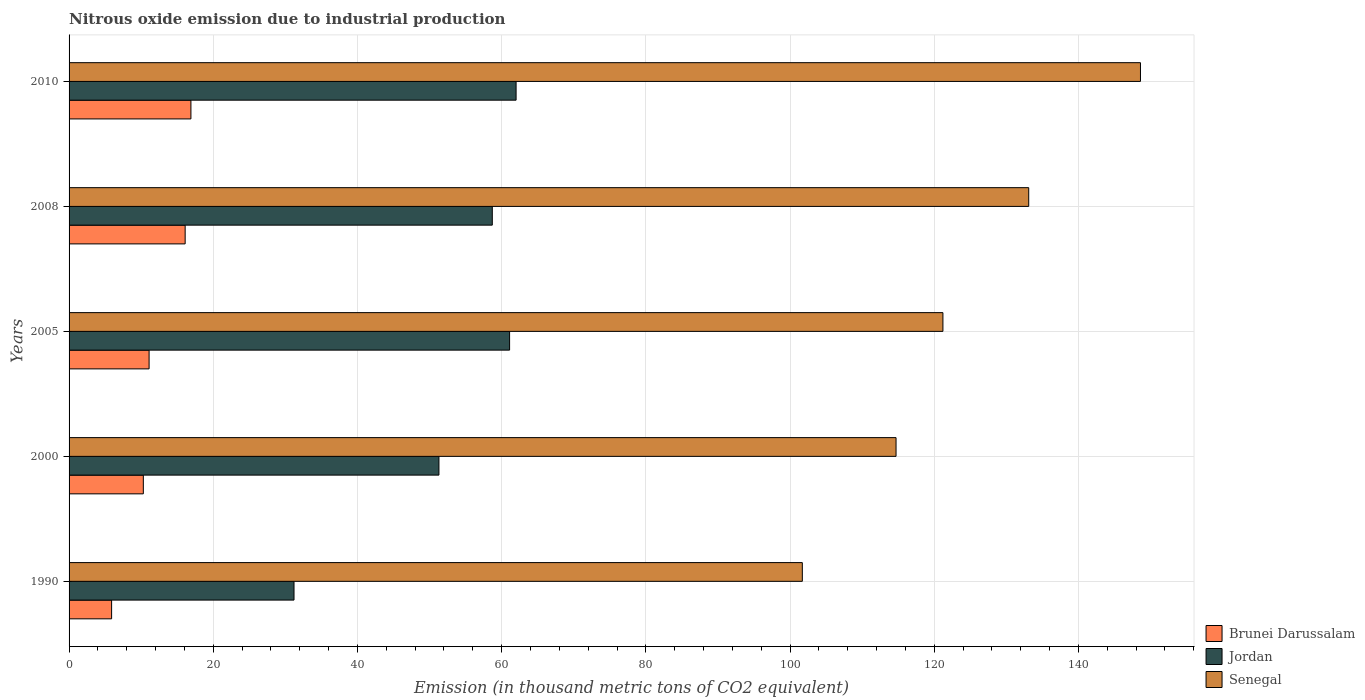How many groups of bars are there?
Offer a very short reply. 5. Are the number of bars per tick equal to the number of legend labels?
Offer a very short reply. Yes. Are the number of bars on each tick of the Y-axis equal?
Ensure brevity in your answer.  Yes. What is the amount of nitrous oxide emitted in Senegal in 2008?
Ensure brevity in your answer.  133.1. Across all years, what is the maximum amount of nitrous oxide emitted in Brunei Darussalam?
Provide a succinct answer. 16.9. In which year was the amount of nitrous oxide emitted in Brunei Darussalam maximum?
Provide a succinct answer. 2010. What is the total amount of nitrous oxide emitted in Senegal in the graph?
Provide a short and direct response. 619.3. What is the difference between the amount of nitrous oxide emitted in Jordan in 1990 and that in 2000?
Offer a very short reply. -20.1. What is the difference between the amount of nitrous oxide emitted in Brunei Darussalam in 2005 and the amount of nitrous oxide emitted in Senegal in 2008?
Keep it short and to the point. -122. What is the average amount of nitrous oxide emitted in Jordan per year?
Give a very brief answer. 52.86. In the year 2008, what is the difference between the amount of nitrous oxide emitted in Brunei Darussalam and amount of nitrous oxide emitted in Senegal?
Provide a succinct answer. -117. What is the ratio of the amount of nitrous oxide emitted in Brunei Darussalam in 2000 to that in 2008?
Your response must be concise. 0.64. What is the difference between the highest and the second highest amount of nitrous oxide emitted in Brunei Darussalam?
Your response must be concise. 0.8. What is the difference between the highest and the lowest amount of nitrous oxide emitted in Senegal?
Keep it short and to the point. 46.9. In how many years, is the amount of nitrous oxide emitted in Jordan greater than the average amount of nitrous oxide emitted in Jordan taken over all years?
Make the answer very short. 3. Is the sum of the amount of nitrous oxide emitted in Brunei Darussalam in 2005 and 2008 greater than the maximum amount of nitrous oxide emitted in Senegal across all years?
Give a very brief answer. No. What does the 3rd bar from the top in 2008 represents?
Offer a very short reply. Brunei Darussalam. What does the 3rd bar from the bottom in 2008 represents?
Provide a short and direct response. Senegal. How many bars are there?
Keep it short and to the point. 15. Are all the bars in the graph horizontal?
Your response must be concise. Yes. What is the difference between two consecutive major ticks on the X-axis?
Provide a short and direct response. 20. Where does the legend appear in the graph?
Ensure brevity in your answer.  Bottom right. What is the title of the graph?
Your answer should be compact. Nitrous oxide emission due to industrial production. Does "Channel Islands" appear as one of the legend labels in the graph?
Your response must be concise. No. What is the label or title of the X-axis?
Offer a terse response. Emission (in thousand metric tons of CO2 equivalent). What is the Emission (in thousand metric tons of CO2 equivalent) of Jordan in 1990?
Offer a very short reply. 31.2. What is the Emission (in thousand metric tons of CO2 equivalent) in Senegal in 1990?
Your response must be concise. 101.7. What is the Emission (in thousand metric tons of CO2 equivalent) of Jordan in 2000?
Offer a very short reply. 51.3. What is the Emission (in thousand metric tons of CO2 equivalent) in Senegal in 2000?
Make the answer very short. 114.7. What is the Emission (in thousand metric tons of CO2 equivalent) of Jordan in 2005?
Your answer should be very brief. 61.1. What is the Emission (in thousand metric tons of CO2 equivalent) of Senegal in 2005?
Ensure brevity in your answer.  121.2. What is the Emission (in thousand metric tons of CO2 equivalent) in Jordan in 2008?
Make the answer very short. 58.7. What is the Emission (in thousand metric tons of CO2 equivalent) in Senegal in 2008?
Offer a terse response. 133.1. What is the Emission (in thousand metric tons of CO2 equivalent) of Brunei Darussalam in 2010?
Your answer should be compact. 16.9. What is the Emission (in thousand metric tons of CO2 equivalent) in Senegal in 2010?
Give a very brief answer. 148.6. Across all years, what is the maximum Emission (in thousand metric tons of CO2 equivalent) in Brunei Darussalam?
Give a very brief answer. 16.9. Across all years, what is the maximum Emission (in thousand metric tons of CO2 equivalent) of Senegal?
Give a very brief answer. 148.6. Across all years, what is the minimum Emission (in thousand metric tons of CO2 equivalent) in Brunei Darussalam?
Keep it short and to the point. 5.9. Across all years, what is the minimum Emission (in thousand metric tons of CO2 equivalent) of Jordan?
Your answer should be compact. 31.2. Across all years, what is the minimum Emission (in thousand metric tons of CO2 equivalent) of Senegal?
Keep it short and to the point. 101.7. What is the total Emission (in thousand metric tons of CO2 equivalent) in Brunei Darussalam in the graph?
Provide a succinct answer. 60.3. What is the total Emission (in thousand metric tons of CO2 equivalent) in Jordan in the graph?
Your answer should be compact. 264.3. What is the total Emission (in thousand metric tons of CO2 equivalent) in Senegal in the graph?
Your answer should be compact. 619.3. What is the difference between the Emission (in thousand metric tons of CO2 equivalent) in Jordan in 1990 and that in 2000?
Give a very brief answer. -20.1. What is the difference between the Emission (in thousand metric tons of CO2 equivalent) of Senegal in 1990 and that in 2000?
Give a very brief answer. -13. What is the difference between the Emission (in thousand metric tons of CO2 equivalent) of Jordan in 1990 and that in 2005?
Give a very brief answer. -29.9. What is the difference between the Emission (in thousand metric tons of CO2 equivalent) of Senegal in 1990 and that in 2005?
Your answer should be very brief. -19.5. What is the difference between the Emission (in thousand metric tons of CO2 equivalent) of Jordan in 1990 and that in 2008?
Keep it short and to the point. -27.5. What is the difference between the Emission (in thousand metric tons of CO2 equivalent) in Senegal in 1990 and that in 2008?
Your answer should be compact. -31.4. What is the difference between the Emission (in thousand metric tons of CO2 equivalent) of Jordan in 1990 and that in 2010?
Make the answer very short. -30.8. What is the difference between the Emission (in thousand metric tons of CO2 equivalent) of Senegal in 1990 and that in 2010?
Provide a short and direct response. -46.9. What is the difference between the Emission (in thousand metric tons of CO2 equivalent) in Brunei Darussalam in 2000 and that in 2005?
Your response must be concise. -0.8. What is the difference between the Emission (in thousand metric tons of CO2 equivalent) of Jordan in 2000 and that in 2005?
Provide a succinct answer. -9.8. What is the difference between the Emission (in thousand metric tons of CO2 equivalent) of Senegal in 2000 and that in 2005?
Offer a very short reply. -6.5. What is the difference between the Emission (in thousand metric tons of CO2 equivalent) of Senegal in 2000 and that in 2008?
Give a very brief answer. -18.4. What is the difference between the Emission (in thousand metric tons of CO2 equivalent) in Senegal in 2000 and that in 2010?
Offer a very short reply. -33.9. What is the difference between the Emission (in thousand metric tons of CO2 equivalent) in Brunei Darussalam in 2005 and that in 2010?
Ensure brevity in your answer.  -5.8. What is the difference between the Emission (in thousand metric tons of CO2 equivalent) in Senegal in 2005 and that in 2010?
Your answer should be compact. -27.4. What is the difference between the Emission (in thousand metric tons of CO2 equivalent) of Brunei Darussalam in 2008 and that in 2010?
Provide a succinct answer. -0.8. What is the difference between the Emission (in thousand metric tons of CO2 equivalent) in Senegal in 2008 and that in 2010?
Give a very brief answer. -15.5. What is the difference between the Emission (in thousand metric tons of CO2 equivalent) of Brunei Darussalam in 1990 and the Emission (in thousand metric tons of CO2 equivalent) of Jordan in 2000?
Provide a succinct answer. -45.4. What is the difference between the Emission (in thousand metric tons of CO2 equivalent) of Brunei Darussalam in 1990 and the Emission (in thousand metric tons of CO2 equivalent) of Senegal in 2000?
Your answer should be compact. -108.8. What is the difference between the Emission (in thousand metric tons of CO2 equivalent) of Jordan in 1990 and the Emission (in thousand metric tons of CO2 equivalent) of Senegal in 2000?
Ensure brevity in your answer.  -83.5. What is the difference between the Emission (in thousand metric tons of CO2 equivalent) of Brunei Darussalam in 1990 and the Emission (in thousand metric tons of CO2 equivalent) of Jordan in 2005?
Give a very brief answer. -55.2. What is the difference between the Emission (in thousand metric tons of CO2 equivalent) in Brunei Darussalam in 1990 and the Emission (in thousand metric tons of CO2 equivalent) in Senegal in 2005?
Ensure brevity in your answer.  -115.3. What is the difference between the Emission (in thousand metric tons of CO2 equivalent) in Jordan in 1990 and the Emission (in thousand metric tons of CO2 equivalent) in Senegal in 2005?
Keep it short and to the point. -90. What is the difference between the Emission (in thousand metric tons of CO2 equivalent) in Brunei Darussalam in 1990 and the Emission (in thousand metric tons of CO2 equivalent) in Jordan in 2008?
Ensure brevity in your answer.  -52.8. What is the difference between the Emission (in thousand metric tons of CO2 equivalent) of Brunei Darussalam in 1990 and the Emission (in thousand metric tons of CO2 equivalent) of Senegal in 2008?
Keep it short and to the point. -127.2. What is the difference between the Emission (in thousand metric tons of CO2 equivalent) of Jordan in 1990 and the Emission (in thousand metric tons of CO2 equivalent) of Senegal in 2008?
Your answer should be very brief. -101.9. What is the difference between the Emission (in thousand metric tons of CO2 equivalent) in Brunei Darussalam in 1990 and the Emission (in thousand metric tons of CO2 equivalent) in Jordan in 2010?
Ensure brevity in your answer.  -56.1. What is the difference between the Emission (in thousand metric tons of CO2 equivalent) of Brunei Darussalam in 1990 and the Emission (in thousand metric tons of CO2 equivalent) of Senegal in 2010?
Your answer should be very brief. -142.7. What is the difference between the Emission (in thousand metric tons of CO2 equivalent) of Jordan in 1990 and the Emission (in thousand metric tons of CO2 equivalent) of Senegal in 2010?
Your response must be concise. -117.4. What is the difference between the Emission (in thousand metric tons of CO2 equivalent) of Brunei Darussalam in 2000 and the Emission (in thousand metric tons of CO2 equivalent) of Jordan in 2005?
Your answer should be very brief. -50.8. What is the difference between the Emission (in thousand metric tons of CO2 equivalent) in Brunei Darussalam in 2000 and the Emission (in thousand metric tons of CO2 equivalent) in Senegal in 2005?
Make the answer very short. -110.9. What is the difference between the Emission (in thousand metric tons of CO2 equivalent) in Jordan in 2000 and the Emission (in thousand metric tons of CO2 equivalent) in Senegal in 2005?
Your answer should be very brief. -69.9. What is the difference between the Emission (in thousand metric tons of CO2 equivalent) in Brunei Darussalam in 2000 and the Emission (in thousand metric tons of CO2 equivalent) in Jordan in 2008?
Keep it short and to the point. -48.4. What is the difference between the Emission (in thousand metric tons of CO2 equivalent) in Brunei Darussalam in 2000 and the Emission (in thousand metric tons of CO2 equivalent) in Senegal in 2008?
Keep it short and to the point. -122.8. What is the difference between the Emission (in thousand metric tons of CO2 equivalent) of Jordan in 2000 and the Emission (in thousand metric tons of CO2 equivalent) of Senegal in 2008?
Your answer should be compact. -81.8. What is the difference between the Emission (in thousand metric tons of CO2 equivalent) in Brunei Darussalam in 2000 and the Emission (in thousand metric tons of CO2 equivalent) in Jordan in 2010?
Provide a short and direct response. -51.7. What is the difference between the Emission (in thousand metric tons of CO2 equivalent) in Brunei Darussalam in 2000 and the Emission (in thousand metric tons of CO2 equivalent) in Senegal in 2010?
Your response must be concise. -138.3. What is the difference between the Emission (in thousand metric tons of CO2 equivalent) in Jordan in 2000 and the Emission (in thousand metric tons of CO2 equivalent) in Senegal in 2010?
Your answer should be very brief. -97.3. What is the difference between the Emission (in thousand metric tons of CO2 equivalent) in Brunei Darussalam in 2005 and the Emission (in thousand metric tons of CO2 equivalent) in Jordan in 2008?
Your answer should be very brief. -47.6. What is the difference between the Emission (in thousand metric tons of CO2 equivalent) in Brunei Darussalam in 2005 and the Emission (in thousand metric tons of CO2 equivalent) in Senegal in 2008?
Your answer should be very brief. -122. What is the difference between the Emission (in thousand metric tons of CO2 equivalent) in Jordan in 2005 and the Emission (in thousand metric tons of CO2 equivalent) in Senegal in 2008?
Make the answer very short. -72. What is the difference between the Emission (in thousand metric tons of CO2 equivalent) in Brunei Darussalam in 2005 and the Emission (in thousand metric tons of CO2 equivalent) in Jordan in 2010?
Your answer should be very brief. -50.9. What is the difference between the Emission (in thousand metric tons of CO2 equivalent) in Brunei Darussalam in 2005 and the Emission (in thousand metric tons of CO2 equivalent) in Senegal in 2010?
Your response must be concise. -137.5. What is the difference between the Emission (in thousand metric tons of CO2 equivalent) of Jordan in 2005 and the Emission (in thousand metric tons of CO2 equivalent) of Senegal in 2010?
Your answer should be very brief. -87.5. What is the difference between the Emission (in thousand metric tons of CO2 equivalent) of Brunei Darussalam in 2008 and the Emission (in thousand metric tons of CO2 equivalent) of Jordan in 2010?
Give a very brief answer. -45.9. What is the difference between the Emission (in thousand metric tons of CO2 equivalent) of Brunei Darussalam in 2008 and the Emission (in thousand metric tons of CO2 equivalent) of Senegal in 2010?
Your response must be concise. -132.5. What is the difference between the Emission (in thousand metric tons of CO2 equivalent) of Jordan in 2008 and the Emission (in thousand metric tons of CO2 equivalent) of Senegal in 2010?
Provide a succinct answer. -89.9. What is the average Emission (in thousand metric tons of CO2 equivalent) of Brunei Darussalam per year?
Offer a very short reply. 12.06. What is the average Emission (in thousand metric tons of CO2 equivalent) of Jordan per year?
Offer a terse response. 52.86. What is the average Emission (in thousand metric tons of CO2 equivalent) of Senegal per year?
Provide a succinct answer. 123.86. In the year 1990, what is the difference between the Emission (in thousand metric tons of CO2 equivalent) of Brunei Darussalam and Emission (in thousand metric tons of CO2 equivalent) of Jordan?
Provide a succinct answer. -25.3. In the year 1990, what is the difference between the Emission (in thousand metric tons of CO2 equivalent) in Brunei Darussalam and Emission (in thousand metric tons of CO2 equivalent) in Senegal?
Ensure brevity in your answer.  -95.8. In the year 1990, what is the difference between the Emission (in thousand metric tons of CO2 equivalent) of Jordan and Emission (in thousand metric tons of CO2 equivalent) of Senegal?
Your answer should be compact. -70.5. In the year 2000, what is the difference between the Emission (in thousand metric tons of CO2 equivalent) of Brunei Darussalam and Emission (in thousand metric tons of CO2 equivalent) of Jordan?
Keep it short and to the point. -41. In the year 2000, what is the difference between the Emission (in thousand metric tons of CO2 equivalent) of Brunei Darussalam and Emission (in thousand metric tons of CO2 equivalent) of Senegal?
Offer a very short reply. -104.4. In the year 2000, what is the difference between the Emission (in thousand metric tons of CO2 equivalent) in Jordan and Emission (in thousand metric tons of CO2 equivalent) in Senegal?
Keep it short and to the point. -63.4. In the year 2005, what is the difference between the Emission (in thousand metric tons of CO2 equivalent) of Brunei Darussalam and Emission (in thousand metric tons of CO2 equivalent) of Senegal?
Your answer should be compact. -110.1. In the year 2005, what is the difference between the Emission (in thousand metric tons of CO2 equivalent) of Jordan and Emission (in thousand metric tons of CO2 equivalent) of Senegal?
Provide a succinct answer. -60.1. In the year 2008, what is the difference between the Emission (in thousand metric tons of CO2 equivalent) in Brunei Darussalam and Emission (in thousand metric tons of CO2 equivalent) in Jordan?
Your answer should be compact. -42.6. In the year 2008, what is the difference between the Emission (in thousand metric tons of CO2 equivalent) in Brunei Darussalam and Emission (in thousand metric tons of CO2 equivalent) in Senegal?
Make the answer very short. -117. In the year 2008, what is the difference between the Emission (in thousand metric tons of CO2 equivalent) of Jordan and Emission (in thousand metric tons of CO2 equivalent) of Senegal?
Your response must be concise. -74.4. In the year 2010, what is the difference between the Emission (in thousand metric tons of CO2 equivalent) of Brunei Darussalam and Emission (in thousand metric tons of CO2 equivalent) of Jordan?
Ensure brevity in your answer.  -45.1. In the year 2010, what is the difference between the Emission (in thousand metric tons of CO2 equivalent) of Brunei Darussalam and Emission (in thousand metric tons of CO2 equivalent) of Senegal?
Your answer should be compact. -131.7. In the year 2010, what is the difference between the Emission (in thousand metric tons of CO2 equivalent) of Jordan and Emission (in thousand metric tons of CO2 equivalent) of Senegal?
Give a very brief answer. -86.6. What is the ratio of the Emission (in thousand metric tons of CO2 equivalent) of Brunei Darussalam in 1990 to that in 2000?
Make the answer very short. 0.57. What is the ratio of the Emission (in thousand metric tons of CO2 equivalent) of Jordan in 1990 to that in 2000?
Provide a short and direct response. 0.61. What is the ratio of the Emission (in thousand metric tons of CO2 equivalent) of Senegal in 1990 to that in 2000?
Provide a succinct answer. 0.89. What is the ratio of the Emission (in thousand metric tons of CO2 equivalent) in Brunei Darussalam in 1990 to that in 2005?
Ensure brevity in your answer.  0.53. What is the ratio of the Emission (in thousand metric tons of CO2 equivalent) of Jordan in 1990 to that in 2005?
Make the answer very short. 0.51. What is the ratio of the Emission (in thousand metric tons of CO2 equivalent) of Senegal in 1990 to that in 2005?
Your answer should be very brief. 0.84. What is the ratio of the Emission (in thousand metric tons of CO2 equivalent) in Brunei Darussalam in 1990 to that in 2008?
Ensure brevity in your answer.  0.37. What is the ratio of the Emission (in thousand metric tons of CO2 equivalent) of Jordan in 1990 to that in 2008?
Keep it short and to the point. 0.53. What is the ratio of the Emission (in thousand metric tons of CO2 equivalent) of Senegal in 1990 to that in 2008?
Keep it short and to the point. 0.76. What is the ratio of the Emission (in thousand metric tons of CO2 equivalent) in Brunei Darussalam in 1990 to that in 2010?
Provide a succinct answer. 0.35. What is the ratio of the Emission (in thousand metric tons of CO2 equivalent) of Jordan in 1990 to that in 2010?
Provide a succinct answer. 0.5. What is the ratio of the Emission (in thousand metric tons of CO2 equivalent) of Senegal in 1990 to that in 2010?
Make the answer very short. 0.68. What is the ratio of the Emission (in thousand metric tons of CO2 equivalent) in Brunei Darussalam in 2000 to that in 2005?
Make the answer very short. 0.93. What is the ratio of the Emission (in thousand metric tons of CO2 equivalent) of Jordan in 2000 to that in 2005?
Offer a very short reply. 0.84. What is the ratio of the Emission (in thousand metric tons of CO2 equivalent) of Senegal in 2000 to that in 2005?
Your response must be concise. 0.95. What is the ratio of the Emission (in thousand metric tons of CO2 equivalent) in Brunei Darussalam in 2000 to that in 2008?
Keep it short and to the point. 0.64. What is the ratio of the Emission (in thousand metric tons of CO2 equivalent) in Jordan in 2000 to that in 2008?
Offer a very short reply. 0.87. What is the ratio of the Emission (in thousand metric tons of CO2 equivalent) in Senegal in 2000 to that in 2008?
Give a very brief answer. 0.86. What is the ratio of the Emission (in thousand metric tons of CO2 equivalent) in Brunei Darussalam in 2000 to that in 2010?
Provide a short and direct response. 0.61. What is the ratio of the Emission (in thousand metric tons of CO2 equivalent) in Jordan in 2000 to that in 2010?
Give a very brief answer. 0.83. What is the ratio of the Emission (in thousand metric tons of CO2 equivalent) in Senegal in 2000 to that in 2010?
Your answer should be very brief. 0.77. What is the ratio of the Emission (in thousand metric tons of CO2 equivalent) of Brunei Darussalam in 2005 to that in 2008?
Offer a very short reply. 0.69. What is the ratio of the Emission (in thousand metric tons of CO2 equivalent) in Jordan in 2005 to that in 2008?
Provide a short and direct response. 1.04. What is the ratio of the Emission (in thousand metric tons of CO2 equivalent) of Senegal in 2005 to that in 2008?
Keep it short and to the point. 0.91. What is the ratio of the Emission (in thousand metric tons of CO2 equivalent) of Brunei Darussalam in 2005 to that in 2010?
Provide a succinct answer. 0.66. What is the ratio of the Emission (in thousand metric tons of CO2 equivalent) in Jordan in 2005 to that in 2010?
Offer a terse response. 0.99. What is the ratio of the Emission (in thousand metric tons of CO2 equivalent) of Senegal in 2005 to that in 2010?
Your answer should be compact. 0.82. What is the ratio of the Emission (in thousand metric tons of CO2 equivalent) in Brunei Darussalam in 2008 to that in 2010?
Your response must be concise. 0.95. What is the ratio of the Emission (in thousand metric tons of CO2 equivalent) in Jordan in 2008 to that in 2010?
Ensure brevity in your answer.  0.95. What is the ratio of the Emission (in thousand metric tons of CO2 equivalent) in Senegal in 2008 to that in 2010?
Give a very brief answer. 0.9. What is the difference between the highest and the second highest Emission (in thousand metric tons of CO2 equivalent) in Brunei Darussalam?
Your answer should be compact. 0.8. What is the difference between the highest and the lowest Emission (in thousand metric tons of CO2 equivalent) in Jordan?
Your answer should be very brief. 30.8. What is the difference between the highest and the lowest Emission (in thousand metric tons of CO2 equivalent) of Senegal?
Offer a terse response. 46.9. 